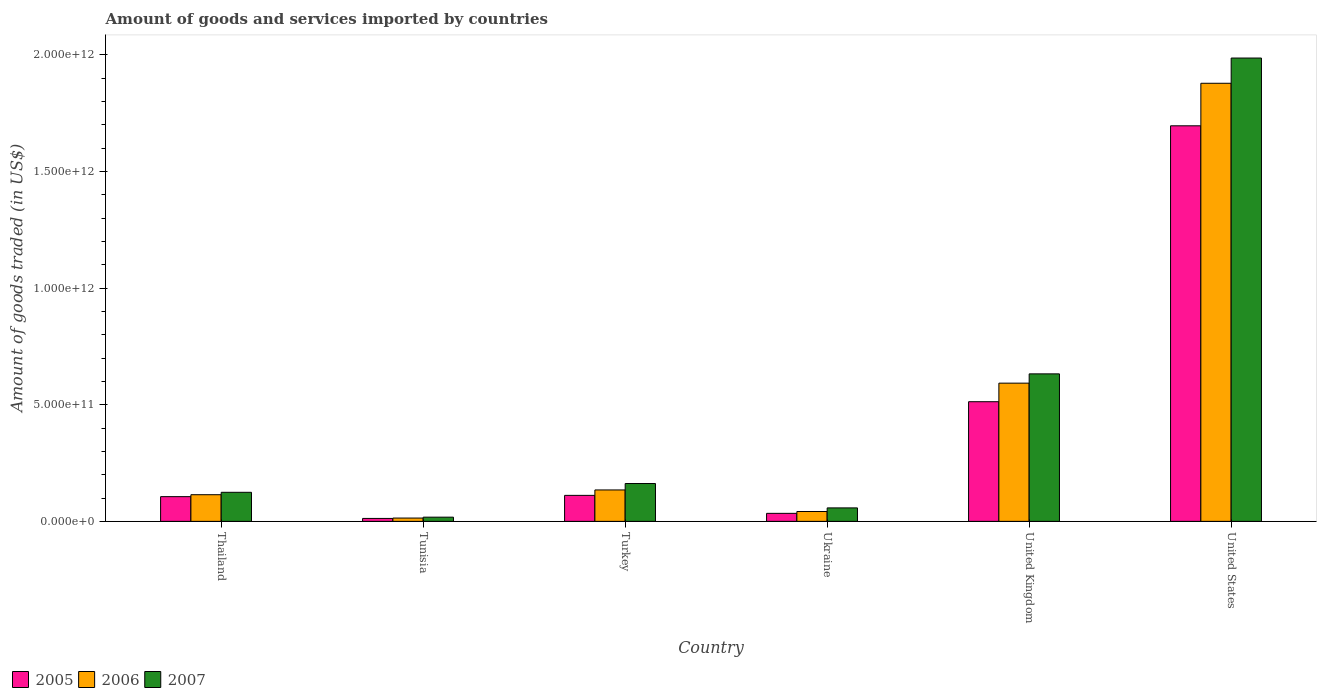How many different coloured bars are there?
Provide a succinct answer. 3. Are the number of bars per tick equal to the number of legend labels?
Ensure brevity in your answer.  Yes. How many bars are there on the 6th tick from the right?
Give a very brief answer. 3. What is the label of the 1st group of bars from the left?
Your answer should be compact. Thailand. In how many cases, is the number of bars for a given country not equal to the number of legend labels?
Keep it short and to the point. 0. What is the total amount of goods and services imported in 2005 in United States?
Your response must be concise. 1.70e+12. Across all countries, what is the maximum total amount of goods and services imported in 2006?
Provide a short and direct response. 1.88e+12. Across all countries, what is the minimum total amount of goods and services imported in 2006?
Your answer should be compact. 1.42e+1. In which country was the total amount of goods and services imported in 2007 minimum?
Ensure brevity in your answer.  Tunisia. What is the total total amount of goods and services imported in 2006 in the graph?
Give a very brief answer. 2.78e+12. What is the difference between the total amount of goods and services imported in 2007 in United Kingdom and that in United States?
Offer a terse response. -1.35e+12. What is the difference between the total amount of goods and services imported in 2005 in Ukraine and the total amount of goods and services imported in 2007 in Tunisia?
Provide a short and direct response. 1.64e+1. What is the average total amount of goods and services imported in 2006 per country?
Make the answer very short. 4.63e+11. What is the difference between the total amount of goods and services imported of/in 2006 and total amount of goods and services imported of/in 2007 in United States?
Your response must be concise. -1.08e+11. What is the ratio of the total amount of goods and services imported in 2006 in Ukraine to that in United Kingdom?
Offer a very short reply. 0.07. Is the total amount of goods and services imported in 2005 in Tunisia less than that in United Kingdom?
Your answer should be very brief. Yes. What is the difference between the highest and the second highest total amount of goods and services imported in 2007?
Your answer should be very brief. 1.82e+12. What is the difference between the highest and the lowest total amount of goods and services imported in 2005?
Your answer should be compact. 1.68e+12. In how many countries, is the total amount of goods and services imported in 2006 greater than the average total amount of goods and services imported in 2006 taken over all countries?
Provide a short and direct response. 2. Is the sum of the total amount of goods and services imported in 2007 in Tunisia and Ukraine greater than the maximum total amount of goods and services imported in 2005 across all countries?
Keep it short and to the point. No. How many bars are there?
Offer a very short reply. 18. How many countries are there in the graph?
Offer a very short reply. 6. What is the difference between two consecutive major ticks on the Y-axis?
Your answer should be very brief. 5.00e+11. Are the values on the major ticks of Y-axis written in scientific E-notation?
Offer a very short reply. Yes. Where does the legend appear in the graph?
Offer a terse response. Bottom left. How many legend labels are there?
Provide a succinct answer. 3. What is the title of the graph?
Keep it short and to the point. Amount of goods and services imported by countries. What is the label or title of the Y-axis?
Your response must be concise. Amount of goods traded (in US$). What is the Amount of goods traded (in US$) of 2005 in Thailand?
Your response must be concise. 1.06e+11. What is the Amount of goods traded (in US$) in 2006 in Thailand?
Your answer should be very brief. 1.14e+11. What is the Amount of goods traded (in US$) in 2007 in Thailand?
Your response must be concise. 1.25e+11. What is the Amount of goods traded (in US$) in 2005 in Tunisia?
Your answer should be very brief. 1.26e+1. What is the Amount of goods traded (in US$) of 2006 in Tunisia?
Provide a succinct answer. 1.42e+1. What is the Amount of goods traded (in US$) of 2007 in Tunisia?
Your answer should be very brief. 1.80e+1. What is the Amount of goods traded (in US$) of 2005 in Turkey?
Ensure brevity in your answer.  1.11e+11. What is the Amount of goods traded (in US$) of 2006 in Turkey?
Keep it short and to the point. 1.35e+11. What is the Amount of goods traded (in US$) of 2007 in Turkey?
Make the answer very short. 1.62e+11. What is the Amount of goods traded (in US$) of 2005 in Ukraine?
Your response must be concise. 3.44e+1. What is the Amount of goods traded (in US$) in 2006 in Ukraine?
Keep it short and to the point. 4.22e+1. What is the Amount of goods traded (in US$) in 2007 in Ukraine?
Keep it short and to the point. 5.78e+1. What is the Amount of goods traded (in US$) in 2005 in United Kingdom?
Your answer should be compact. 5.13e+11. What is the Amount of goods traded (in US$) of 2006 in United Kingdom?
Keep it short and to the point. 5.93e+11. What is the Amount of goods traded (in US$) in 2007 in United Kingdom?
Offer a terse response. 6.32e+11. What is the Amount of goods traded (in US$) of 2005 in United States?
Your answer should be very brief. 1.70e+12. What is the Amount of goods traded (in US$) of 2006 in United States?
Keep it short and to the point. 1.88e+12. What is the Amount of goods traded (in US$) of 2007 in United States?
Ensure brevity in your answer.  1.99e+12. Across all countries, what is the maximum Amount of goods traded (in US$) of 2005?
Offer a terse response. 1.70e+12. Across all countries, what is the maximum Amount of goods traded (in US$) in 2006?
Keep it short and to the point. 1.88e+12. Across all countries, what is the maximum Amount of goods traded (in US$) in 2007?
Provide a short and direct response. 1.99e+12. Across all countries, what is the minimum Amount of goods traded (in US$) in 2005?
Offer a terse response. 1.26e+1. Across all countries, what is the minimum Amount of goods traded (in US$) in 2006?
Offer a very short reply. 1.42e+1. Across all countries, what is the minimum Amount of goods traded (in US$) in 2007?
Provide a succinct answer. 1.80e+1. What is the total Amount of goods traded (in US$) of 2005 in the graph?
Provide a short and direct response. 2.47e+12. What is the total Amount of goods traded (in US$) of 2006 in the graph?
Your response must be concise. 2.78e+12. What is the total Amount of goods traded (in US$) in 2007 in the graph?
Make the answer very short. 2.98e+12. What is the difference between the Amount of goods traded (in US$) in 2005 in Thailand and that in Tunisia?
Offer a very short reply. 9.34e+1. What is the difference between the Amount of goods traded (in US$) of 2006 in Thailand and that in Tunisia?
Your answer should be very brief. 1.00e+11. What is the difference between the Amount of goods traded (in US$) in 2007 in Thailand and that in Tunisia?
Keep it short and to the point. 1.07e+11. What is the difference between the Amount of goods traded (in US$) in 2005 in Thailand and that in Turkey?
Your answer should be very brief. -5.47e+09. What is the difference between the Amount of goods traded (in US$) in 2006 in Thailand and that in Turkey?
Your answer should be compact. -2.04e+1. What is the difference between the Amount of goods traded (in US$) in 2007 in Thailand and that in Turkey?
Offer a terse response. -3.76e+1. What is the difference between the Amount of goods traded (in US$) of 2005 in Thailand and that in Ukraine?
Give a very brief answer. 7.16e+1. What is the difference between the Amount of goods traded (in US$) in 2006 in Thailand and that in Ukraine?
Your response must be concise. 7.20e+1. What is the difference between the Amount of goods traded (in US$) of 2007 in Thailand and that in Ukraine?
Keep it short and to the point. 6.69e+1. What is the difference between the Amount of goods traded (in US$) of 2005 in Thailand and that in United Kingdom?
Provide a succinct answer. -4.07e+11. What is the difference between the Amount of goods traded (in US$) in 2006 in Thailand and that in United Kingdom?
Your answer should be very brief. -4.78e+11. What is the difference between the Amount of goods traded (in US$) of 2007 in Thailand and that in United Kingdom?
Provide a succinct answer. -5.08e+11. What is the difference between the Amount of goods traded (in US$) of 2005 in Thailand and that in United States?
Keep it short and to the point. -1.59e+12. What is the difference between the Amount of goods traded (in US$) in 2006 in Thailand and that in United States?
Ensure brevity in your answer.  -1.76e+12. What is the difference between the Amount of goods traded (in US$) of 2007 in Thailand and that in United States?
Your response must be concise. -1.86e+12. What is the difference between the Amount of goods traded (in US$) of 2005 in Tunisia and that in Turkey?
Make the answer very short. -9.89e+1. What is the difference between the Amount of goods traded (in US$) of 2006 in Tunisia and that in Turkey?
Make the answer very short. -1.20e+11. What is the difference between the Amount of goods traded (in US$) in 2007 in Tunisia and that in Turkey?
Your answer should be very brief. -1.44e+11. What is the difference between the Amount of goods traded (in US$) in 2005 in Tunisia and that in Ukraine?
Ensure brevity in your answer.  -2.18e+1. What is the difference between the Amount of goods traded (in US$) of 2006 in Tunisia and that in Ukraine?
Offer a terse response. -2.80e+1. What is the difference between the Amount of goods traded (in US$) in 2007 in Tunisia and that in Ukraine?
Your response must be concise. -3.97e+1. What is the difference between the Amount of goods traded (in US$) of 2005 in Tunisia and that in United Kingdom?
Provide a succinct answer. -5.00e+11. What is the difference between the Amount of goods traded (in US$) of 2006 in Tunisia and that in United Kingdom?
Offer a terse response. -5.78e+11. What is the difference between the Amount of goods traded (in US$) of 2007 in Tunisia and that in United Kingdom?
Ensure brevity in your answer.  -6.14e+11. What is the difference between the Amount of goods traded (in US$) in 2005 in Tunisia and that in United States?
Provide a short and direct response. -1.68e+12. What is the difference between the Amount of goods traded (in US$) of 2006 in Tunisia and that in United States?
Make the answer very short. -1.86e+12. What is the difference between the Amount of goods traded (in US$) of 2007 in Tunisia and that in United States?
Your answer should be compact. -1.97e+12. What is the difference between the Amount of goods traded (in US$) of 2005 in Turkey and that in Ukraine?
Your answer should be very brief. 7.71e+1. What is the difference between the Amount of goods traded (in US$) of 2006 in Turkey and that in Ukraine?
Provide a short and direct response. 9.25e+1. What is the difference between the Amount of goods traded (in US$) of 2007 in Turkey and that in Ukraine?
Give a very brief answer. 1.04e+11. What is the difference between the Amount of goods traded (in US$) of 2005 in Turkey and that in United Kingdom?
Keep it short and to the point. -4.02e+11. What is the difference between the Amount of goods traded (in US$) of 2006 in Turkey and that in United Kingdom?
Provide a succinct answer. -4.58e+11. What is the difference between the Amount of goods traded (in US$) in 2007 in Turkey and that in United Kingdom?
Offer a terse response. -4.70e+11. What is the difference between the Amount of goods traded (in US$) of 2005 in Turkey and that in United States?
Offer a terse response. -1.58e+12. What is the difference between the Amount of goods traded (in US$) in 2006 in Turkey and that in United States?
Give a very brief answer. -1.74e+12. What is the difference between the Amount of goods traded (in US$) in 2007 in Turkey and that in United States?
Offer a terse response. -1.82e+12. What is the difference between the Amount of goods traded (in US$) in 2005 in Ukraine and that in United Kingdom?
Ensure brevity in your answer.  -4.79e+11. What is the difference between the Amount of goods traded (in US$) in 2006 in Ukraine and that in United Kingdom?
Provide a succinct answer. -5.50e+11. What is the difference between the Amount of goods traded (in US$) in 2007 in Ukraine and that in United Kingdom?
Make the answer very short. -5.75e+11. What is the difference between the Amount of goods traded (in US$) of 2005 in Ukraine and that in United States?
Your answer should be very brief. -1.66e+12. What is the difference between the Amount of goods traded (in US$) of 2006 in Ukraine and that in United States?
Give a very brief answer. -1.84e+12. What is the difference between the Amount of goods traded (in US$) in 2007 in Ukraine and that in United States?
Offer a very short reply. -1.93e+12. What is the difference between the Amount of goods traded (in US$) in 2005 in United Kingdom and that in United States?
Keep it short and to the point. -1.18e+12. What is the difference between the Amount of goods traded (in US$) in 2006 in United Kingdom and that in United States?
Your answer should be compact. -1.29e+12. What is the difference between the Amount of goods traded (in US$) in 2007 in United Kingdom and that in United States?
Give a very brief answer. -1.35e+12. What is the difference between the Amount of goods traded (in US$) in 2005 in Thailand and the Amount of goods traded (in US$) in 2006 in Tunisia?
Give a very brief answer. 9.18e+1. What is the difference between the Amount of goods traded (in US$) in 2005 in Thailand and the Amount of goods traded (in US$) in 2007 in Tunisia?
Provide a succinct answer. 8.80e+1. What is the difference between the Amount of goods traded (in US$) of 2006 in Thailand and the Amount of goods traded (in US$) of 2007 in Tunisia?
Provide a short and direct response. 9.62e+1. What is the difference between the Amount of goods traded (in US$) of 2005 in Thailand and the Amount of goods traded (in US$) of 2006 in Turkey?
Offer a terse response. -2.87e+1. What is the difference between the Amount of goods traded (in US$) of 2005 in Thailand and the Amount of goods traded (in US$) of 2007 in Turkey?
Make the answer very short. -5.62e+1. What is the difference between the Amount of goods traded (in US$) in 2006 in Thailand and the Amount of goods traded (in US$) in 2007 in Turkey?
Your answer should be compact. -4.79e+1. What is the difference between the Amount of goods traded (in US$) in 2005 in Thailand and the Amount of goods traded (in US$) in 2006 in Ukraine?
Offer a very short reply. 6.38e+1. What is the difference between the Amount of goods traded (in US$) in 2005 in Thailand and the Amount of goods traded (in US$) in 2007 in Ukraine?
Ensure brevity in your answer.  4.82e+1. What is the difference between the Amount of goods traded (in US$) of 2006 in Thailand and the Amount of goods traded (in US$) of 2007 in Ukraine?
Your response must be concise. 5.65e+1. What is the difference between the Amount of goods traded (in US$) of 2005 in Thailand and the Amount of goods traded (in US$) of 2006 in United Kingdom?
Offer a terse response. -4.87e+11. What is the difference between the Amount of goods traded (in US$) of 2005 in Thailand and the Amount of goods traded (in US$) of 2007 in United Kingdom?
Give a very brief answer. -5.26e+11. What is the difference between the Amount of goods traded (in US$) of 2006 in Thailand and the Amount of goods traded (in US$) of 2007 in United Kingdom?
Provide a short and direct response. -5.18e+11. What is the difference between the Amount of goods traded (in US$) in 2005 in Thailand and the Amount of goods traded (in US$) in 2006 in United States?
Your response must be concise. -1.77e+12. What is the difference between the Amount of goods traded (in US$) in 2005 in Thailand and the Amount of goods traded (in US$) in 2007 in United States?
Your answer should be compact. -1.88e+12. What is the difference between the Amount of goods traded (in US$) of 2006 in Thailand and the Amount of goods traded (in US$) of 2007 in United States?
Your response must be concise. -1.87e+12. What is the difference between the Amount of goods traded (in US$) of 2005 in Tunisia and the Amount of goods traded (in US$) of 2006 in Turkey?
Your response must be concise. -1.22e+11. What is the difference between the Amount of goods traded (in US$) of 2005 in Tunisia and the Amount of goods traded (in US$) of 2007 in Turkey?
Provide a short and direct response. -1.50e+11. What is the difference between the Amount of goods traded (in US$) of 2006 in Tunisia and the Amount of goods traded (in US$) of 2007 in Turkey?
Offer a very short reply. -1.48e+11. What is the difference between the Amount of goods traded (in US$) in 2005 in Tunisia and the Amount of goods traded (in US$) in 2006 in Ukraine?
Keep it short and to the point. -2.96e+1. What is the difference between the Amount of goods traded (in US$) of 2005 in Tunisia and the Amount of goods traded (in US$) of 2007 in Ukraine?
Your answer should be compact. -4.52e+1. What is the difference between the Amount of goods traded (in US$) in 2006 in Tunisia and the Amount of goods traded (in US$) in 2007 in Ukraine?
Keep it short and to the point. -4.36e+1. What is the difference between the Amount of goods traded (in US$) in 2005 in Tunisia and the Amount of goods traded (in US$) in 2006 in United Kingdom?
Give a very brief answer. -5.80e+11. What is the difference between the Amount of goods traded (in US$) in 2005 in Tunisia and the Amount of goods traded (in US$) in 2007 in United Kingdom?
Your answer should be compact. -6.20e+11. What is the difference between the Amount of goods traded (in US$) of 2006 in Tunisia and the Amount of goods traded (in US$) of 2007 in United Kingdom?
Give a very brief answer. -6.18e+11. What is the difference between the Amount of goods traded (in US$) of 2005 in Tunisia and the Amount of goods traded (in US$) of 2006 in United States?
Give a very brief answer. -1.87e+12. What is the difference between the Amount of goods traded (in US$) of 2005 in Tunisia and the Amount of goods traded (in US$) of 2007 in United States?
Provide a short and direct response. -1.97e+12. What is the difference between the Amount of goods traded (in US$) of 2006 in Tunisia and the Amount of goods traded (in US$) of 2007 in United States?
Provide a short and direct response. -1.97e+12. What is the difference between the Amount of goods traded (in US$) in 2005 in Turkey and the Amount of goods traded (in US$) in 2006 in Ukraine?
Your answer should be compact. 6.92e+1. What is the difference between the Amount of goods traded (in US$) in 2005 in Turkey and the Amount of goods traded (in US$) in 2007 in Ukraine?
Give a very brief answer. 5.37e+1. What is the difference between the Amount of goods traded (in US$) of 2006 in Turkey and the Amount of goods traded (in US$) of 2007 in Ukraine?
Your answer should be compact. 7.69e+1. What is the difference between the Amount of goods traded (in US$) in 2005 in Turkey and the Amount of goods traded (in US$) in 2006 in United Kingdom?
Your answer should be very brief. -4.81e+11. What is the difference between the Amount of goods traded (in US$) in 2005 in Turkey and the Amount of goods traded (in US$) in 2007 in United Kingdom?
Offer a terse response. -5.21e+11. What is the difference between the Amount of goods traded (in US$) of 2006 in Turkey and the Amount of goods traded (in US$) of 2007 in United Kingdom?
Provide a succinct answer. -4.98e+11. What is the difference between the Amount of goods traded (in US$) in 2005 in Turkey and the Amount of goods traded (in US$) in 2006 in United States?
Provide a short and direct response. -1.77e+12. What is the difference between the Amount of goods traded (in US$) in 2005 in Turkey and the Amount of goods traded (in US$) in 2007 in United States?
Your answer should be compact. -1.87e+12. What is the difference between the Amount of goods traded (in US$) in 2006 in Turkey and the Amount of goods traded (in US$) in 2007 in United States?
Keep it short and to the point. -1.85e+12. What is the difference between the Amount of goods traded (in US$) of 2005 in Ukraine and the Amount of goods traded (in US$) of 2006 in United Kingdom?
Your response must be concise. -5.58e+11. What is the difference between the Amount of goods traded (in US$) of 2005 in Ukraine and the Amount of goods traded (in US$) of 2007 in United Kingdom?
Offer a terse response. -5.98e+11. What is the difference between the Amount of goods traded (in US$) in 2006 in Ukraine and the Amount of goods traded (in US$) in 2007 in United Kingdom?
Your answer should be compact. -5.90e+11. What is the difference between the Amount of goods traded (in US$) of 2005 in Ukraine and the Amount of goods traded (in US$) of 2006 in United States?
Provide a short and direct response. -1.84e+12. What is the difference between the Amount of goods traded (in US$) in 2005 in Ukraine and the Amount of goods traded (in US$) in 2007 in United States?
Your answer should be very brief. -1.95e+12. What is the difference between the Amount of goods traded (in US$) in 2006 in Ukraine and the Amount of goods traded (in US$) in 2007 in United States?
Keep it short and to the point. -1.94e+12. What is the difference between the Amount of goods traded (in US$) of 2005 in United Kingdom and the Amount of goods traded (in US$) of 2006 in United States?
Give a very brief answer. -1.37e+12. What is the difference between the Amount of goods traded (in US$) of 2005 in United Kingdom and the Amount of goods traded (in US$) of 2007 in United States?
Give a very brief answer. -1.47e+12. What is the difference between the Amount of goods traded (in US$) of 2006 in United Kingdom and the Amount of goods traded (in US$) of 2007 in United States?
Your answer should be compact. -1.39e+12. What is the average Amount of goods traded (in US$) of 2005 per country?
Offer a terse response. 4.12e+11. What is the average Amount of goods traded (in US$) of 2006 per country?
Provide a succinct answer. 4.63e+11. What is the average Amount of goods traded (in US$) of 2007 per country?
Ensure brevity in your answer.  4.97e+11. What is the difference between the Amount of goods traded (in US$) of 2005 and Amount of goods traded (in US$) of 2006 in Thailand?
Offer a terse response. -8.29e+09. What is the difference between the Amount of goods traded (in US$) in 2005 and Amount of goods traded (in US$) in 2007 in Thailand?
Offer a terse response. -1.86e+1. What is the difference between the Amount of goods traded (in US$) of 2006 and Amount of goods traded (in US$) of 2007 in Thailand?
Your response must be concise. -1.03e+1. What is the difference between the Amount of goods traded (in US$) in 2005 and Amount of goods traded (in US$) in 2006 in Tunisia?
Your response must be concise. -1.61e+09. What is the difference between the Amount of goods traded (in US$) in 2005 and Amount of goods traded (in US$) in 2007 in Tunisia?
Keep it short and to the point. -5.43e+09. What is the difference between the Amount of goods traded (in US$) of 2006 and Amount of goods traded (in US$) of 2007 in Tunisia?
Your response must be concise. -3.82e+09. What is the difference between the Amount of goods traded (in US$) in 2005 and Amount of goods traded (in US$) in 2006 in Turkey?
Your answer should be compact. -2.32e+1. What is the difference between the Amount of goods traded (in US$) in 2005 and Amount of goods traded (in US$) in 2007 in Turkey?
Your response must be concise. -5.08e+1. What is the difference between the Amount of goods traded (in US$) in 2006 and Amount of goods traded (in US$) in 2007 in Turkey?
Keep it short and to the point. -2.75e+1. What is the difference between the Amount of goods traded (in US$) of 2005 and Amount of goods traded (in US$) of 2006 in Ukraine?
Make the answer very short. -7.84e+09. What is the difference between the Amount of goods traded (in US$) in 2005 and Amount of goods traded (in US$) in 2007 in Ukraine?
Offer a terse response. -2.34e+1. What is the difference between the Amount of goods traded (in US$) of 2006 and Amount of goods traded (in US$) of 2007 in Ukraine?
Provide a succinct answer. -1.55e+1. What is the difference between the Amount of goods traded (in US$) of 2005 and Amount of goods traded (in US$) of 2006 in United Kingdom?
Your answer should be very brief. -7.96e+1. What is the difference between the Amount of goods traded (in US$) in 2005 and Amount of goods traded (in US$) in 2007 in United Kingdom?
Offer a terse response. -1.19e+11. What is the difference between the Amount of goods traded (in US$) of 2006 and Amount of goods traded (in US$) of 2007 in United Kingdom?
Give a very brief answer. -3.98e+1. What is the difference between the Amount of goods traded (in US$) in 2005 and Amount of goods traded (in US$) in 2006 in United States?
Offer a terse response. -1.82e+11. What is the difference between the Amount of goods traded (in US$) in 2005 and Amount of goods traded (in US$) in 2007 in United States?
Offer a terse response. -2.91e+11. What is the difference between the Amount of goods traded (in US$) of 2006 and Amount of goods traded (in US$) of 2007 in United States?
Give a very brief answer. -1.08e+11. What is the ratio of the Amount of goods traded (in US$) of 2005 in Thailand to that in Tunisia?
Your answer should be compact. 8.41. What is the ratio of the Amount of goods traded (in US$) of 2006 in Thailand to that in Tunisia?
Provide a succinct answer. 8.05. What is the ratio of the Amount of goods traded (in US$) of 2007 in Thailand to that in Tunisia?
Offer a terse response. 6.91. What is the ratio of the Amount of goods traded (in US$) of 2005 in Thailand to that in Turkey?
Offer a terse response. 0.95. What is the ratio of the Amount of goods traded (in US$) of 2006 in Thailand to that in Turkey?
Keep it short and to the point. 0.85. What is the ratio of the Amount of goods traded (in US$) in 2007 in Thailand to that in Turkey?
Keep it short and to the point. 0.77. What is the ratio of the Amount of goods traded (in US$) of 2005 in Thailand to that in Ukraine?
Offer a very short reply. 3.08. What is the ratio of the Amount of goods traded (in US$) in 2006 in Thailand to that in Ukraine?
Provide a short and direct response. 2.71. What is the ratio of the Amount of goods traded (in US$) of 2007 in Thailand to that in Ukraine?
Provide a succinct answer. 2.16. What is the ratio of the Amount of goods traded (in US$) in 2005 in Thailand to that in United Kingdom?
Offer a terse response. 0.21. What is the ratio of the Amount of goods traded (in US$) of 2006 in Thailand to that in United Kingdom?
Offer a terse response. 0.19. What is the ratio of the Amount of goods traded (in US$) of 2007 in Thailand to that in United Kingdom?
Offer a very short reply. 0.2. What is the ratio of the Amount of goods traded (in US$) of 2005 in Thailand to that in United States?
Your answer should be compact. 0.06. What is the ratio of the Amount of goods traded (in US$) in 2006 in Thailand to that in United States?
Ensure brevity in your answer.  0.06. What is the ratio of the Amount of goods traded (in US$) of 2007 in Thailand to that in United States?
Offer a very short reply. 0.06. What is the ratio of the Amount of goods traded (in US$) in 2005 in Tunisia to that in Turkey?
Make the answer very short. 0.11. What is the ratio of the Amount of goods traded (in US$) of 2006 in Tunisia to that in Turkey?
Provide a short and direct response. 0.11. What is the ratio of the Amount of goods traded (in US$) of 2007 in Tunisia to that in Turkey?
Your answer should be compact. 0.11. What is the ratio of the Amount of goods traded (in US$) in 2005 in Tunisia to that in Ukraine?
Keep it short and to the point. 0.37. What is the ratio of the Amount of goods traded (in US$) in 2006 in Tunisia to that in Ukraine?
Provide a succinct answer. 0.34. What is the ratio of the Amount of goods traded (in US$) in 2007 in Tunisia to that in Ukraine?
Offer a terse response. 0.31. What is the ratio of the Amount of goods traded (in US$) of 2005 in Tunisia to that in United Kingdom?
Give a very brief answer. 0.02. What is the ratio of the Amount of goods traded (in US$) of 2006 in Tunisia to that in United Kingdom?
Keep it short and to the point. 0.02. What is the ratio of the Amount of goods traded (in US$) in 2007 in Tunisia to that in United Kingdom?
Your answer should be very brief. 0.03. What is the ratio of the Amount of goods traded (in US$) of 2005 in Tunisia to that in United States?
Provide a short and direct response. 0.01. What is the ratio of the Amount of goods traded (in US$) in 2006 in Tunisia to that in United States?
Ensure brevity in your answer.  0.01. What is the ratio of the Amount of goods traded (in US$) of 2007 in Tunisia to that in United States?
Make the answer very short. 0.01. What is the ratio of the Amount of goods traded (in US$) of 2005 in Turkey to that in Ukraine?
Your response must be concise. 3.24. What is the ratio of the Amount of goods traded (in US$) of 2006 in Turkey to that in Ukraine?
Make the answer very short. 3.19. What is the ratio of the Amount of goods traded (in US$) in 2007 in Turkey to that in Ukraine?
Offer a very short reply. 2.81. What is the ratio of the Amount of goods traded (in US$) in 2005 in Turkey to that in United Kingdom?
Your response must be concise. 0.22. What is the ratio of the Amount of goods traded (in US$) of 2006 in Turkey to that in United Kingdom?
Keep it short and to the point. 0.23. What is the ratio of the Amount of goods traded (in US$) in 2007 in Turkey to that in United Kingdom?
Your answer should be very brief. 0.26. What is the ratio of the Amount of goods traded (in US$) of 2005 in Turkey to that in United States?
Provide a short and direct response. 0.07. What is the ratio of the Amount of goods traded (in US$) of 2006 in Turkey to that in United States?
Offer a terse response. 0.07. What is the ratio of the Amount of goods traded (in US$) in 2007 in Turkey to that in United States?
Provide a succinct answer. 0.08. What is the ratio of the Amount of goods traded (in US$) of 2005 in Ukraine to that in United Kingdom?
Offer a terse response. 0.07. What is the ratio of the Amount of goods traded (in US$) in 2006 in Ukraine to that in United Kingdom?
Ensure brevity in your answer.  0.07. What is the ratio of the Amount of goods traded (in US$) in 2007 in Ukraine to that in United Kingdom?
Provide a short and direct response. 0.09. What is the ratio of the Amount of goods traded (in US$) in 2005 in Ukraine to that in United States?
Provide a succinct answer. 0.02. What is the ratio of the Amount of goods traded (in US$) of 2006 in Ukraine to that in United States?
Your answer should be very brief. 0.02. What is the ratio of the Amount of goods traded (in US$) in 2007 in Ukraine to that in United States?
Give a very brief answer. 0.03. What is the ratio of the Amount of goods traded (in US$) in 2005 in United Kingdom to that in United States?
Offer a terse response. 0.3. What is the ratio of the Amount of goods traded (in US$) of 2006 in United Kingdom to that in United States?
Offer a very short reply. 0.32. What is the ratio of the Amount of goods traded (in US$) in 2007 in United Kingdom to that in United States?
Give a very brief answer. 0.32. What is the difference between the highest and the second highest Amount of goods traded (in US$) of 2005?
Offer a terse response. 1.18e+12. What is the difference between the highest and the second highest Amount of goods traded (in US$) of 2006?
Your answer should be very brief. 1.29e+12. What is the difference between the highest and the second highest Amount of goods traded (in US$) of 2007?
Provide a short and direct response. 1.35e+12. What is the difference between the highest and the lowest Amount of goods traded (in US$) of 2005?
Offer a very short reply. 1.68e+12. What is the difference between the highest and the lowest Amount of goods traded (in US$) in 2006?
Offer a very short reply. 1.86e+12. What is the difference between the highest and the lowest Amount of goods traded (in US$) in 2007?
Make the answer very short. 1.97e+12. 